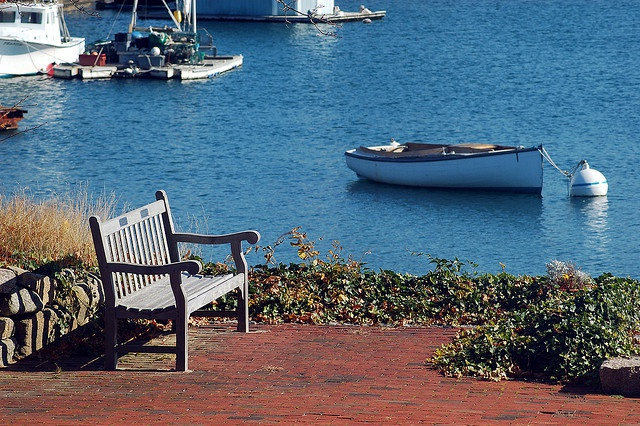Describe the objects in this image and their specific colors. I can see bench in brown, black, lightgray, darkgray, and gray tones, boat in brown, blue, black, and navy tones, boat in brown, black, navy, lightgray, and blue tones, boat in brown, white, darkgray, and gray tones, and boat in brown, black, lightgray, darkgray, and navy tones in this image. 